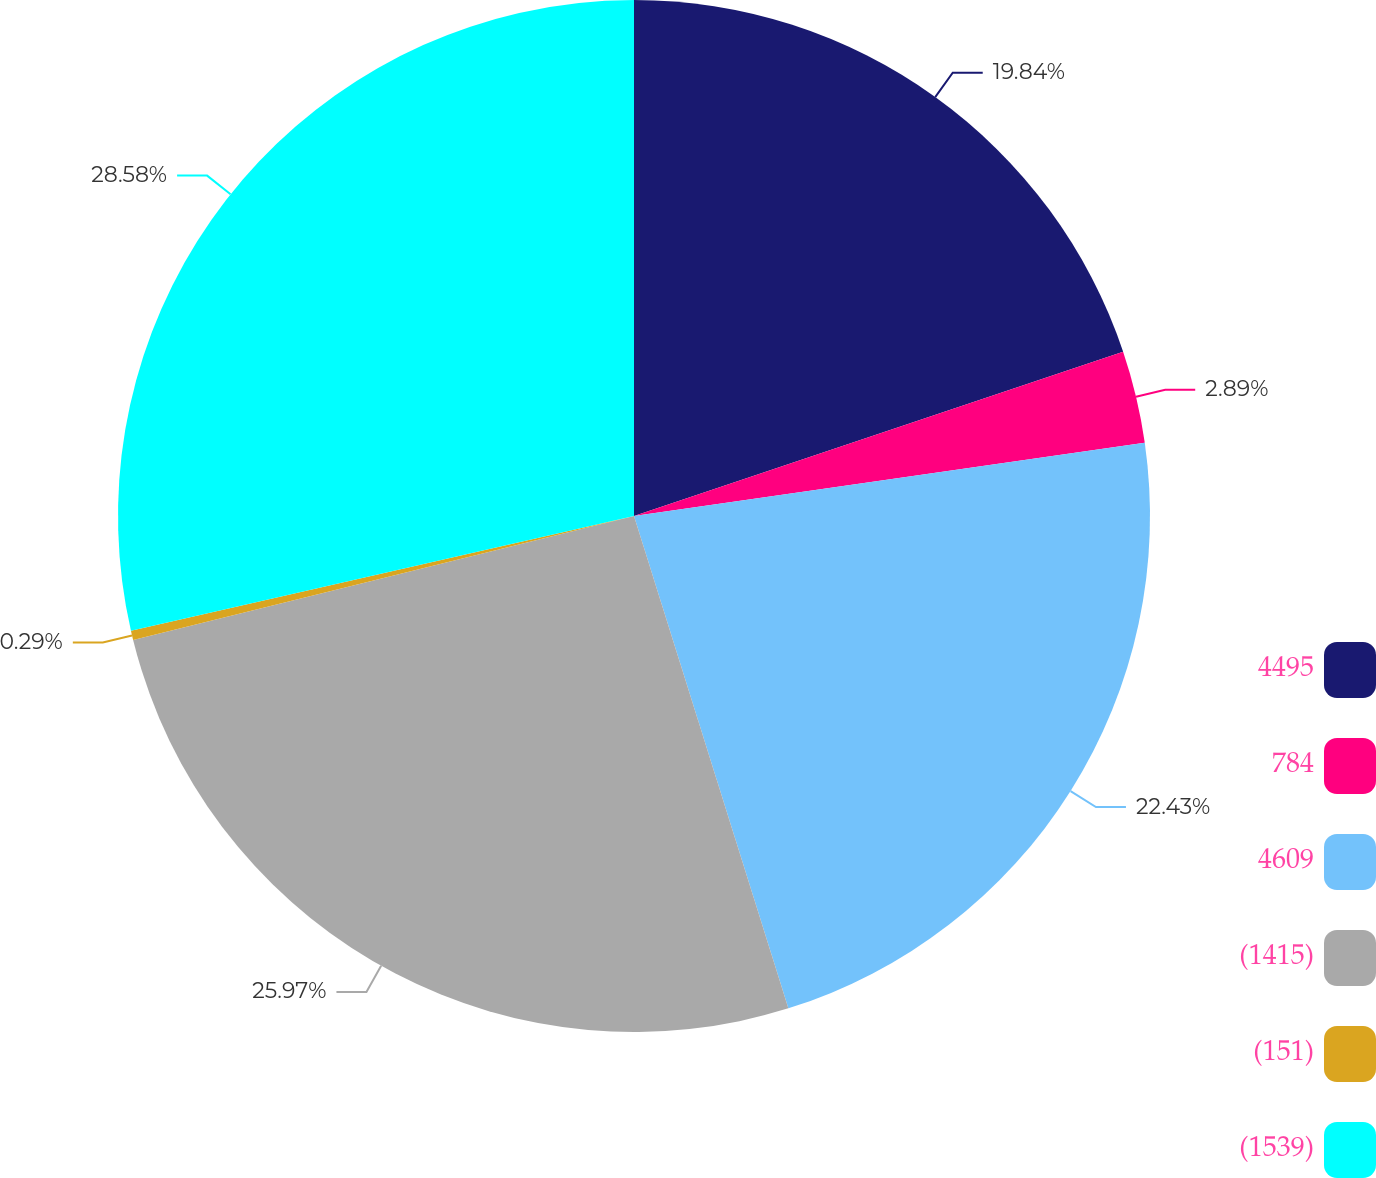Convert chart to OTSL. <chart><loc_0><loc_0><loc_500><loc_500><pie_chart><fcel>4495<fcel>784<fcel>4609<fcel>(1415)<fcel>(151)<fcel>(1539)<nl><fcel>19.84%<fcel>2.89%<fcel>22.43%<fcel>25.97%<fcel>0.29%<fcel>28.57%<nl></chart> 